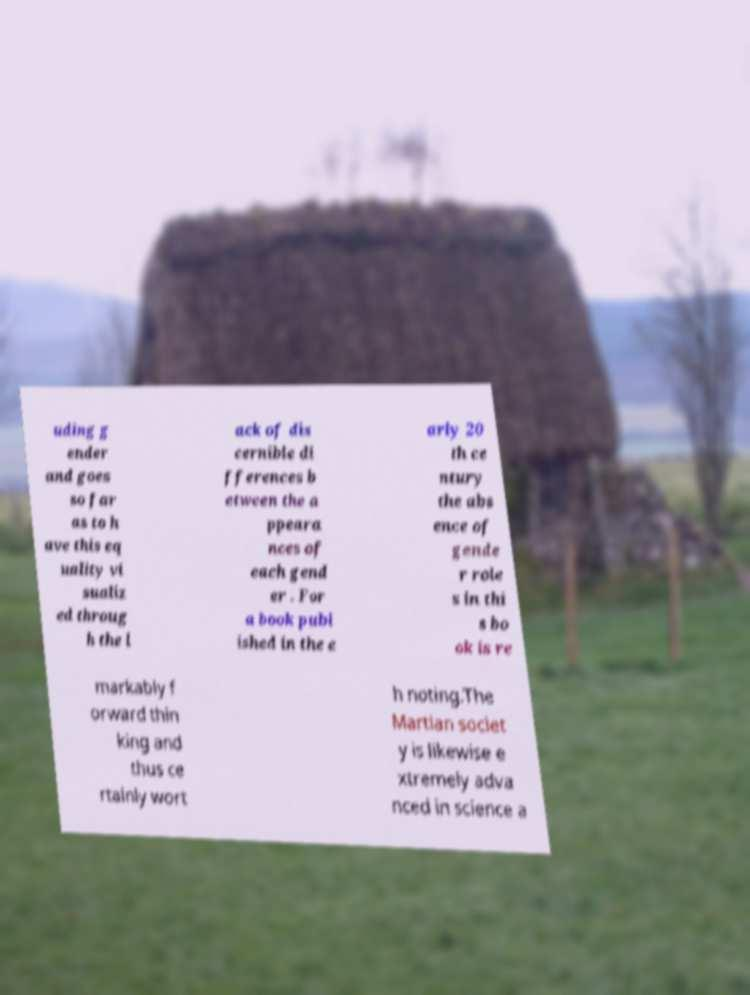Please read and relay the text visible in this image. What does it say? uding g ender and goes so far as to h ave this eq uality vi sualiz ed throug h the l ack of dis cernible di fferences b etween the a ppeara nces of each gend er . For a book publ ished in the e arly 20 th ce ntury the abs ence of gende r role s in thi s bo ok is re markably f orward thin king and thus ce rtainly wort h noting.The Martian societ y is likewise e xtremely adva nced in science a 